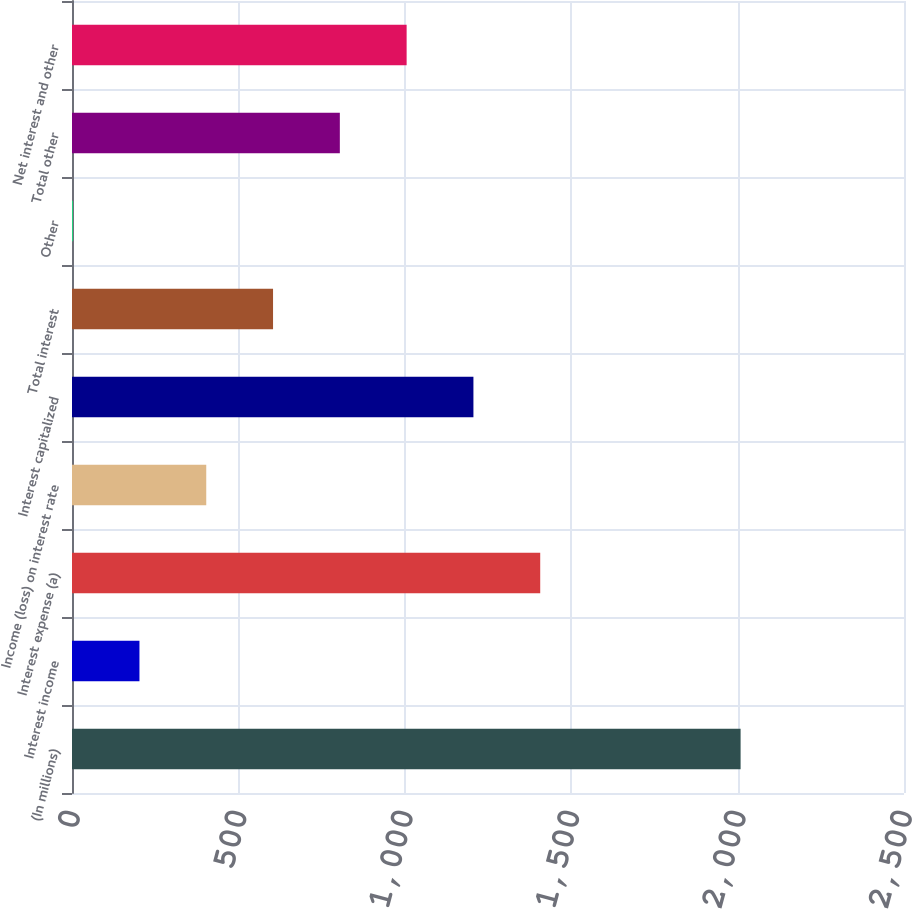Convert chart to OTSL. <chart><loc_0><loc_0><loc_500><loc_500><bar_chart><fcel>(In millions)<fcel>Interest income<fcel>Interest expense (a)<fcel>Income (loss) on interest rate<fcel>Interest capitalized<fcel>Total interest<fcel>Other<fcel>Total other<fcel>Net interest and other<nl><fcel>2009<fcel>202.7<fcel>1406.9<fcel>403.4<fcel>1206.2<fcel>604.1<fcel>2<fcel>804.8<fcel>1005.5<nl></chart> 